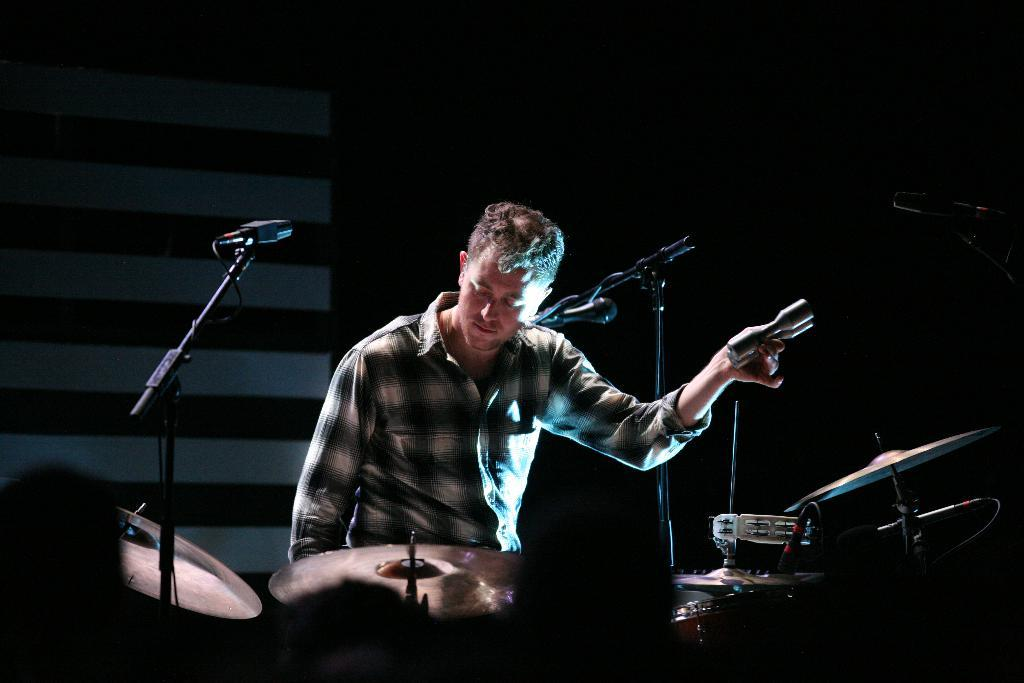What musical instruments are at the bottom of the image? There are drums and microphones at the bottom of the image. Who is positioned near the drums and microphones? A person is sitting behind the drums and microphones. What might the person be doing with the object in his hand? The person is holding something in his hand, which might be used for playing the drums or adjusting the microphones. How many frogs can be seen hopping around the drums in the image? There are no frogs present in the image; it features drums, microphones, and a person. 